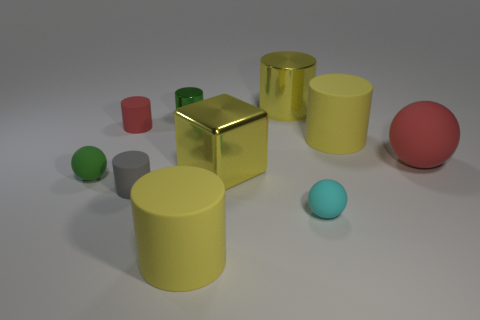Subtract all gray balls. How many yellow cylinders are left? 3 Subtract all yellow cylinders. How many cylinders are left? 3 Subtract all green shiny cylinders. How many cylinders are left? 5 Subtract all blue cylinders. Subtract all purple blocks. How many cylinders are left? 6 Subtract all cubes. How many objects are left? 9 Add 2 tiny objects. How many tiny objects exist? 7 Subtract 0 blue cylinders. How many objects are left? 10 Subtract all small green cylinders. Subtract all large red spheres. How many objects are left? 8 Add 5 yellow metallic cylinders. How many yellow metallic cylinders are left? 6 